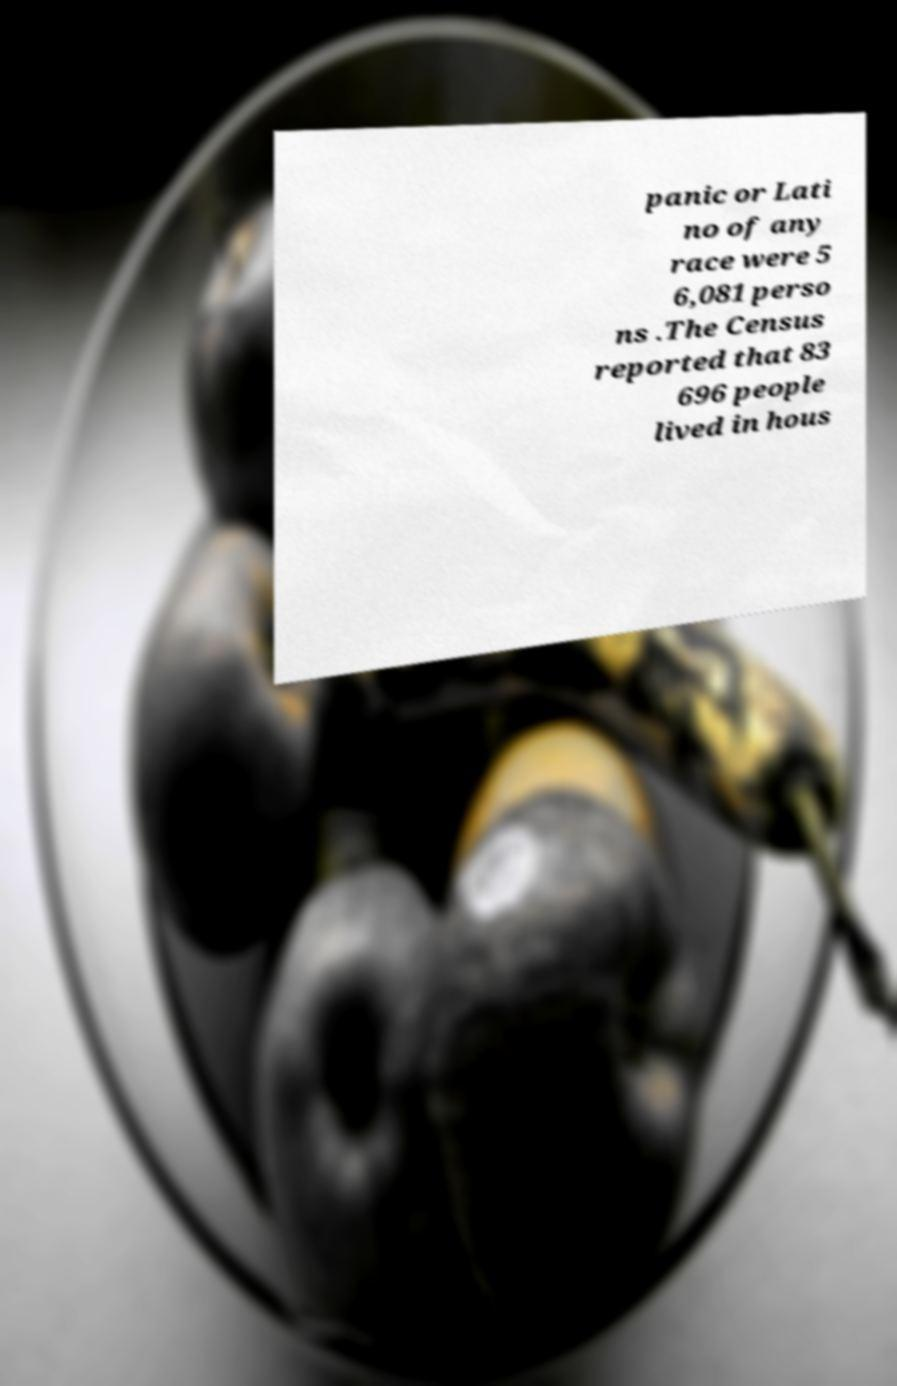Please read and relay the text visible in this image. What does it say? panic or Lati no of any race were 5 6,081 perso ns .The Census reported that 83 696 people lived in hous 